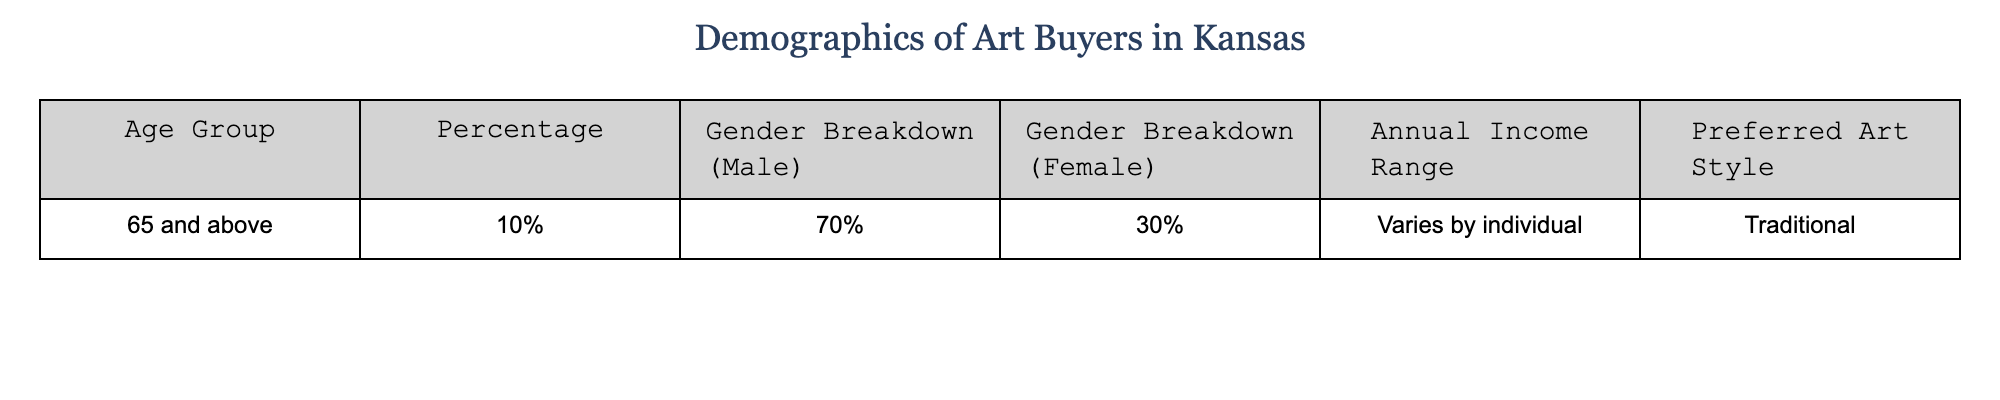What percentage of art buyers in Kansas are aged 65 and above? The table shows that the percentage of art buyers aged 65 and above is listed as 10%.
Answer: 10% What gender is more predominant among art buyers aged 65 and above? According to the gender breakdown in the table, 70% of art buyers aged 65 and above are male, while 30% are female, indicating that males are more predominant.
Answer: Male What is the annual income range for art buyers aged 65 and above? The table states that the annual income range varies by individual, indicating no specific range is provided.
Answer: Varies by individual What is the preferred art style of art buyers aged 65 and above? The table mentions that the preferred art style for this age group is traditional.
Answer: Traditional If 100 art buyers aged 65 and above were surveyed, how many would be male? If 70% of 100 art buyers are male, then the number of males would be calculated as 70% of 100, which is 70.
Answer: 70 Is the majority of art buyers aged 65 and above female? The table shows that 70% of art buyers are male, indicating that the majority are not female.
Answer: No Calculate the percentage difference in gender breakdown between male and female art buyers aged 65 and above. The difference between the percentage of male (70%) and female (30%) art buyers is 70% - 30% = 40%. Thus, the percentage difference is 40%.
Answer: 40% What can be inferred about the art buying preferences of males and females aged 65 and above? Since the table provides a breakdown showing that a majority (70%) are male and that their preferred style is traditional, it can be inferred that traditional art resonates more with male buyers in this age group.
Answer: Traditional art resonates more with males If the percentage of female art buyers in this group were to double, what would their new percentage be? If the female percentage (currently 30%) doubled, it would become 30% x 2 = 60%. However, this would exceed 100% when added to the male percentage, which indicates it's not feasible.
Answer: Not feasible What conclusion can you draw about the demographic trends in art buying for older individuals in Kansas? The table suggests that older individuals (65 and above) tend to have a preference for traditional art, with a significant majority identifying as male, indicating a potential demographic trend towards traditional styles among older male art buyers in Kansas.
Answer: Traditional preference among older males 